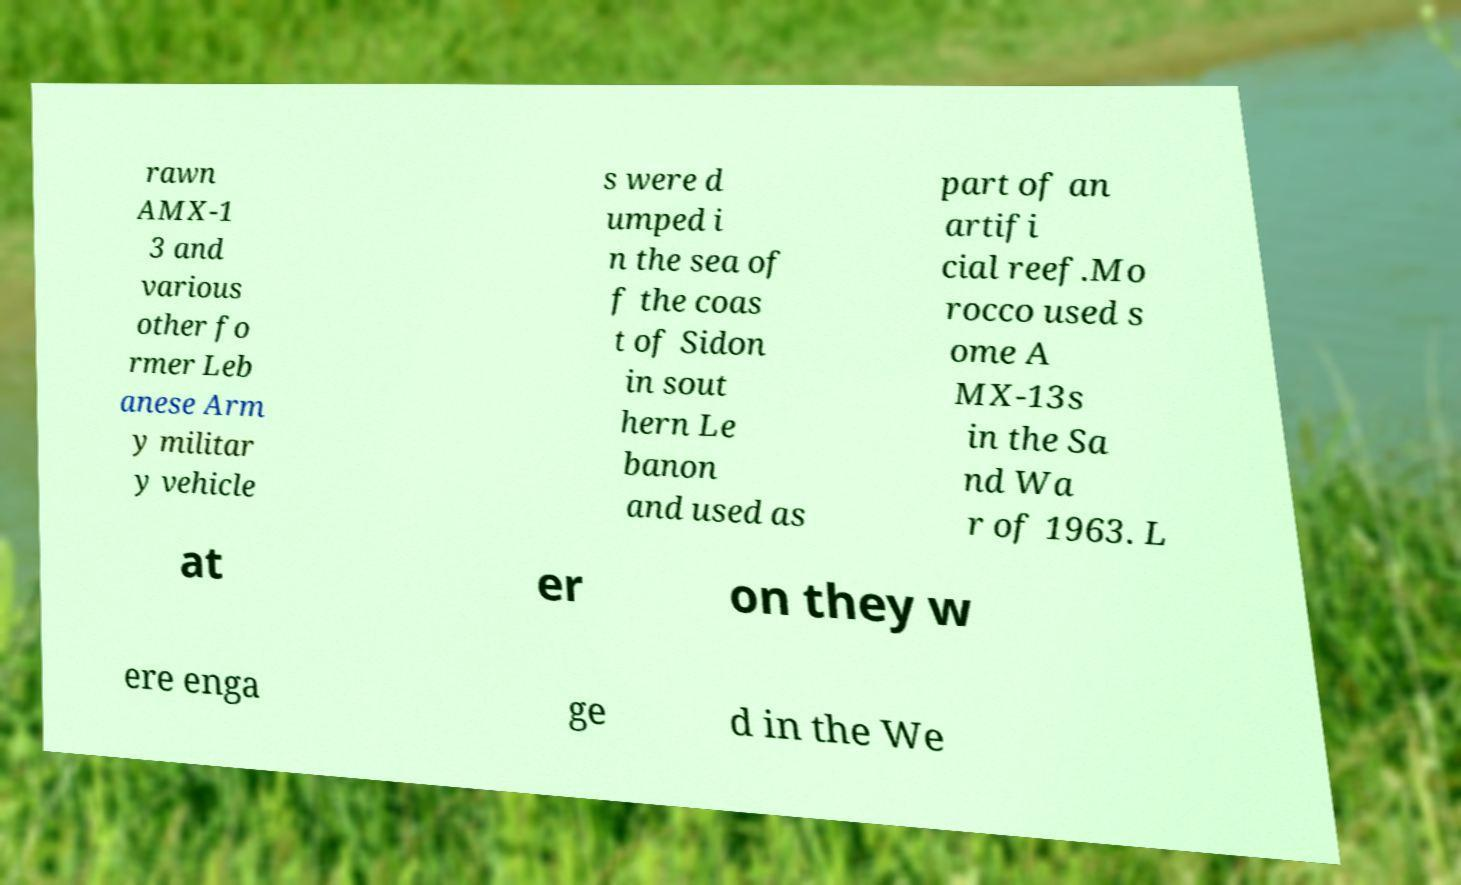There's text embedded in this image that I need extracted. Can you transcribe it verbatim? rawn AMX-1 3 and various other fo rmer Leb anese Arm y militar y vehicle s were d umped i n the sea of f the coas t of Sidon in sout hern Le banon and used as part of an artifi cial reef.Mo rocco used s ome A MX-13s in the Sa nd Wa r of 1963. L at er on they w ere enga ge d in the We 